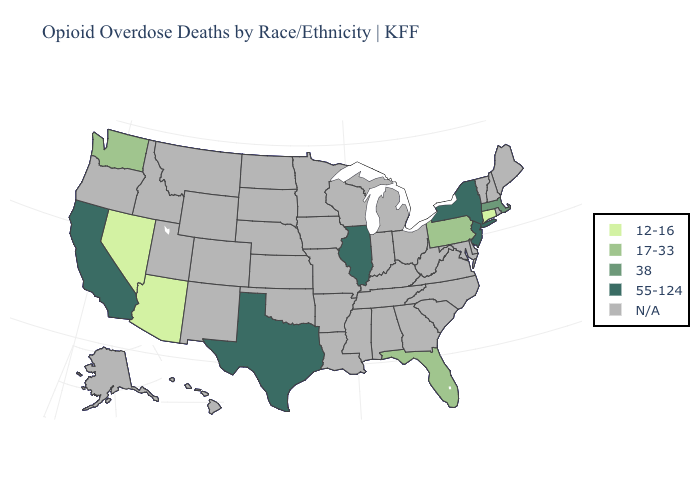Does Texas have the highest value in the South?
Quick response, please. Yes. Name the states that have a value in the range N/A?
Concise answer only. Alabama, Alaska, Arkansas, Colorado, Delaware, Georgia, Hawaii, Idaho, Indiana, Iowa, Kansas, Kentucky, Louisiana, Maine, Maryland, Michigan, Minnesota, Mississippi, Missouri, Montana, Nebraska, New Hampshire, New Mexico, North Carolina, North Dakota, Ohio, Oklahoma, Oregon, Rhode Island, South Carolina, South Dakota, Tennessee, Utah, Vermont, Virginia, West Virginia, Wisconsin, Wyoming. Name the states that have a value in the range 12-16?
Answer briefly. Arizona, Connecticut, Nevada. What is the highest value in states that border Massachusetts?
Keep it brief. 55-124. Name the states that have a value in the range 55-124?
Concise answer only. California, Illinois, New Jersey, New York, Texas. Does the map have missing data?
Answer briefly. Yes. What is the value of Wisconsin?
Write a very short answer. N/A. Name the states that have a value in the range N/A?
Concise answer only. Alabama, Alaska, Arkansas, Colorado, Delaware, Georgia, Hawaii, Idaho, Indiana, Iowa, Kansas, Kentucky, Louisiana, Maine, Maryland, Michigan, Minnesota, Mississippi, Missouri, Montana, Nebraska, New Hampshire, New Mexico, North Carolina, North Dakota, Ohio, Oklahoma, Oregon, Rhode Island, South Carolina, South Dakota, Tennessee, Utah, Vermont, Virginia, West Virginia, Wisconsin, Wyoming. Which states have the lowest value in the USA?
Quick response, please. Arizona, Connecticut, Nevada. What is the value of Nebraska?
Quick response, please. N/A. What is the highest value in the USA?
Concise answer only. 55-124. What is the value of Michigan?
Concise answer only. N/A. 